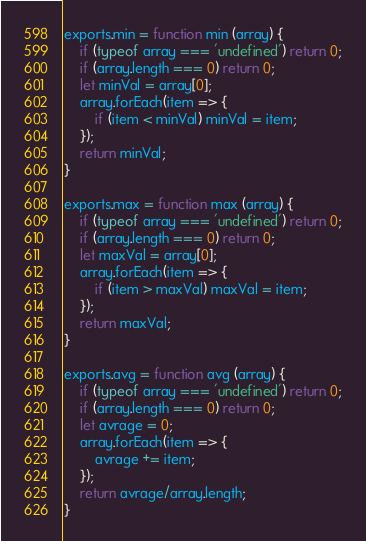<code> <loc_0><loc_0><loc_500><loc_500><_JavaScript_>exports.min = function min (array) {
	if (typeof array === 'undefined') return 0;
	if (array.length === 0) return 0;
	let minVal = array[0];
	array.forEach(item => {
		if (item < minVal) minVal = item;
	});
	return minVal;
}

exports.max = function max (array) {
	if (typeof array === 'undefined') return 0;
	if (array.length === 0) return 0;
	let maxVal = array[0];
	array.forEach(item => {
		if (item > maxVal) maxVal = item;
	});
	return maxVal;
}

exports.avg = function avg (array) {
	if (typeof array === 'undefined') return 0;
	if (array.length === 0) return 0;
	let avrage = 0;
	array.forEach(item => {
		avrage += item;
	});
	return avrage/array.length;
}</code> 